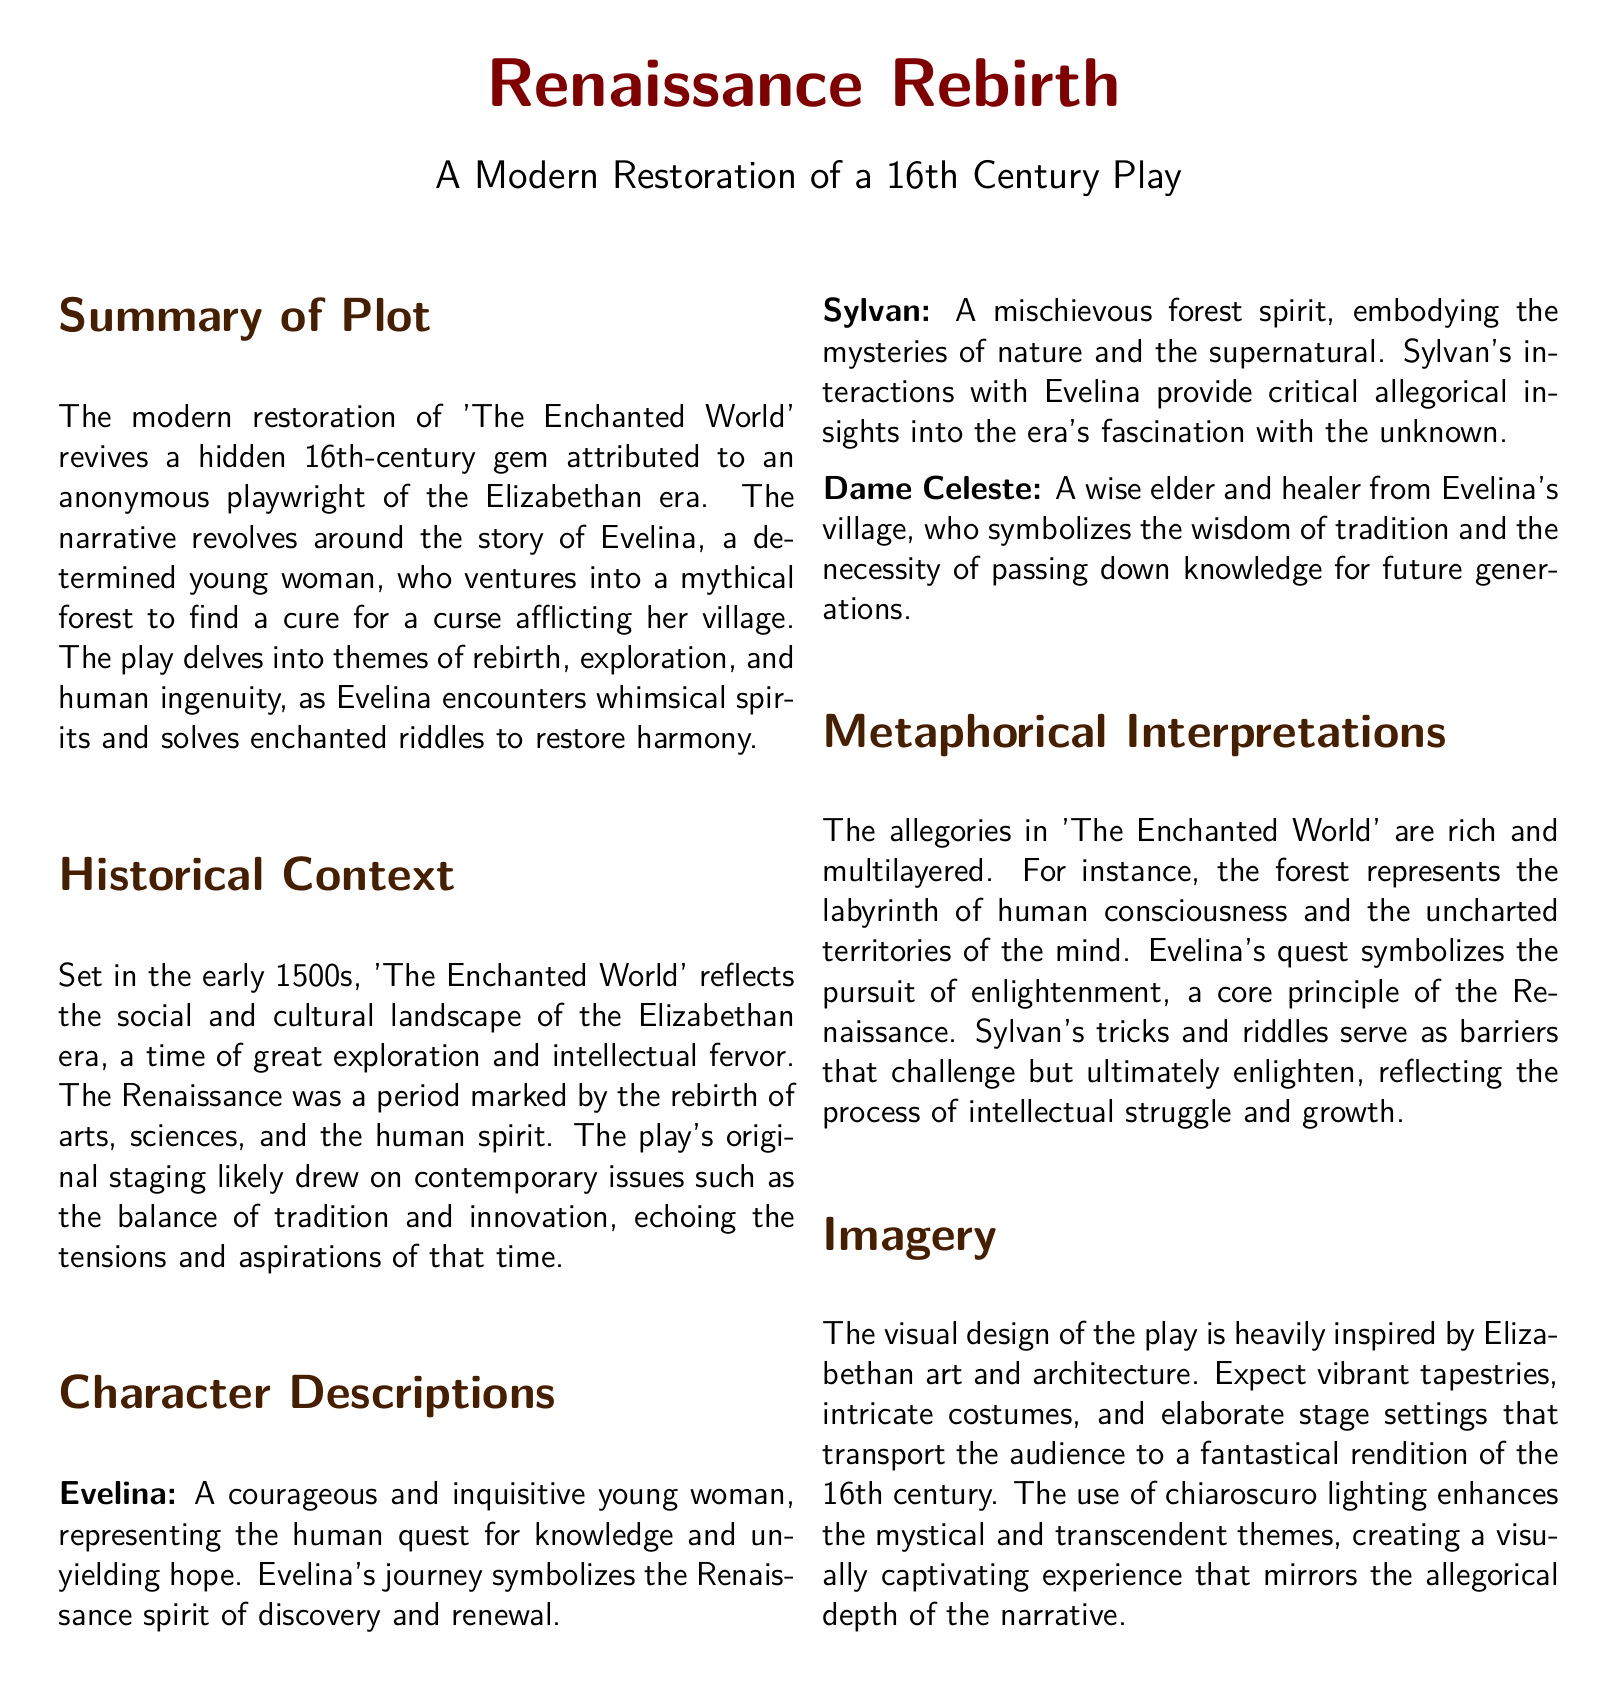What is the title of the play? The title of the play is prominently displayed at the top of the document, stating "Renaissance Rebirth."
Answer: Renaissance Rebirth Who is the protagonist of the play? The document specifically identifies Evelina as the main character in the plot summary.
Answer: Evelina What does Evelina seek in the mythical forest? The plot summary details that Evelina ventures into the forest to find a cure for a curse afflicting her village.
Answer: A cure What role does Sylvan play in the narrative? The character description indicates that Sylvan is a mischievous forest spirit who interacts with Evelina and provides allegorical insights.
Answer: Forest spirit What era is the play set in? The historical context section clearly states that the play is set in the early 1500s during the Renaissance.
Answer: Early 1500s What does the forest symbolize? The metaphorical interpretations mention that the forest represents the labyrinth of human consciousness and the uncharted territories of the mind.
Answer: Labyrinth of human consciousness How does Dame Celeste contribute to the play? The character description explains that Dame Celeste symbolizes the wisdom of tradition and the necessity of passing down knowledge.
Answer: Wisdom of tradition What visual style is utilized in the play? The imagery section discusses the visual design inspired by Elizabethan art and architecture, emphasizing vibrant tapestries and intricate costumes.
Answer: Elizabethan art How many sections are in the document? By counting the section headings within the document, we can determine that there are four main sections present.
Answer: Four 